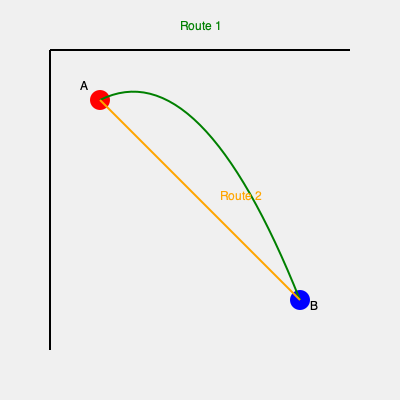Based on the map showing two supply routes between points A and B, which route would be most advantageous for an army to use during a winter campaign in mountainous terrain, and why? To answer this question, we need to analyze the two routes shown on the map:

1. Route 1 (green curve):
   - Longer path
   - Curved trajectory
   - Avoids direct line between A and B

2. Route 2 (orange straight line):
   - Shorter path
   - Direct route between A and B

For a winter campaign in mountainous terrain:

a) Route length: 
   - Shorter routes are generally preferred to minimize exposure to harsh weather.
   - Route 2 is shorter, which is an advantage.

b) Terrain considerations:
   - The curved nature of Route 1 suggests it follows natural contours of the land.
   - This likely means Route 1 avoids steep inclines and declines.
   - Route 2, being direct, might cross over more difficult terrain.

c) Weather impact:
   - In mountainous areas, direct routes often cross high passes, which can be treacherous in winter.
   - The curved path of Route 1 may stay in lower elevations, reducing snow and ice risks.

d) Logistics:
   - While Route 2 is shorter, it may require more energy and resources to traverse in difficult conditions.
   - Route 1, though longer, might be easier to maintain and keep open during winter.

e) Historical context:
   - Historically, armies often preferred established routes that followed natural features, especially in challenging seasons.

Considering these factors, Route 1 (green curve) would be most advantageous. Its curved path likely indicates a route that follows valleys or passes at lower elevations, making it easier to traverse and maintain during harsh winter conditions in mountainous terrain. The longer distance is offset by increased safety and reliability of supply lines.
Answer: Route 1 (green curve) 